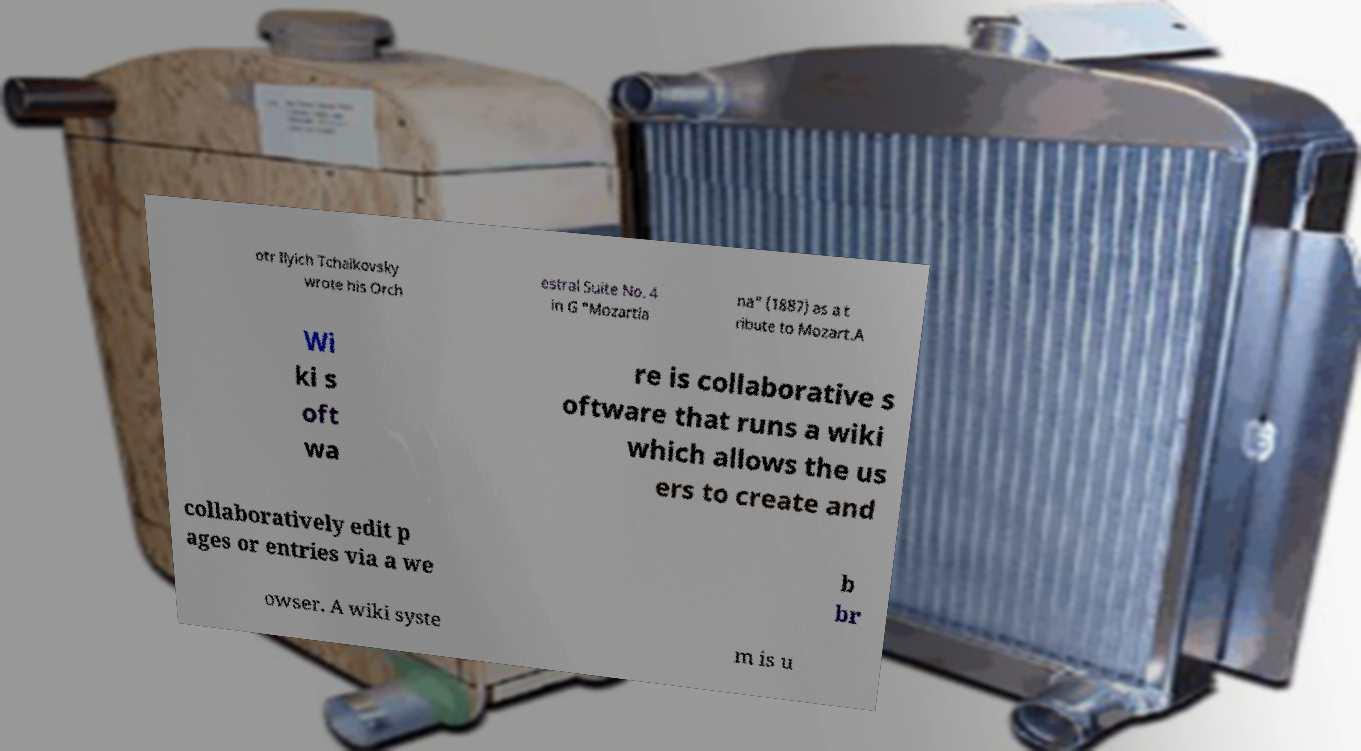Can you accurately transcribe the text from the provided image for me? otr Ilyich Tchaikovsky wrote his Orch estral Suite No. 4 in G "Mozartia na" (1887) as a t ribute to Mozart.A Wi ki s oft wa re is collaborative s oftware that runs a wiki which allows the us ers to create and collaboratively edit p ages or entries via a we b br owser. A wiki syste m is u 